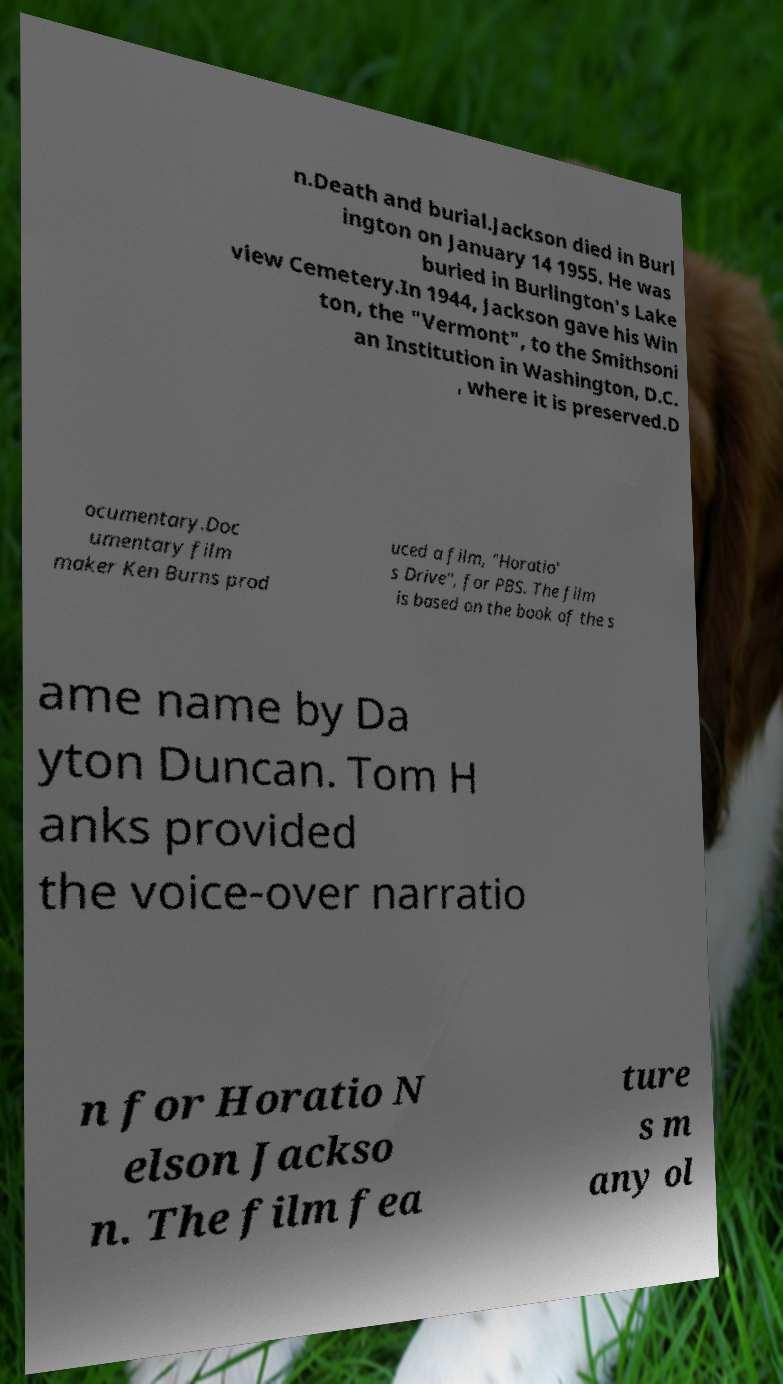Could you extract and type out the text from this image? n.Death and burial.Jackson died in Burl ington on January 14 1955. He was buried in Burlington's Lake view Cemetery.In 1944, Jackson gave his Win ton, the "Vermont", to the Smithsoni an Institution in Washington, D.C. , where it is preserved.D ocumentary.Doc umentary film maker Ken Burns prod uced a film, "Horatio' s Drive", for PBS. The film is based on the book of the s ame name by Da yton Duncan. Tom H anks provided the voice-over narratio n for Horatio N elson Jackso n. The film fea ture s m any ol 